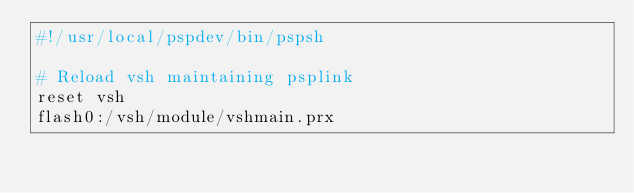Convert code to text. <code><loc_0><loc_0><loc_500><loc_500><_Bash_>#!/usr/local/pspdev/bin/pspsh

# Reload vsh maintaining psplink
reset vsh
flash0:/vsh/module/vshmain.prx
</code> 